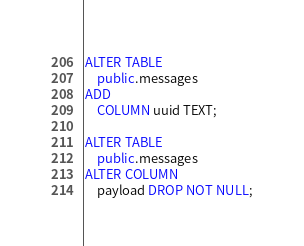Convert code to text. <code><loc_0><loc_0><loc_500><loc_500><_SQL_>ALTER TABLE
    public.messages
ADD
    COLUMN uuid TEXT;

ALTER TABLE
    public.messages
ALTER COLUMN
    payload DROP NOT NULL;
</code> 